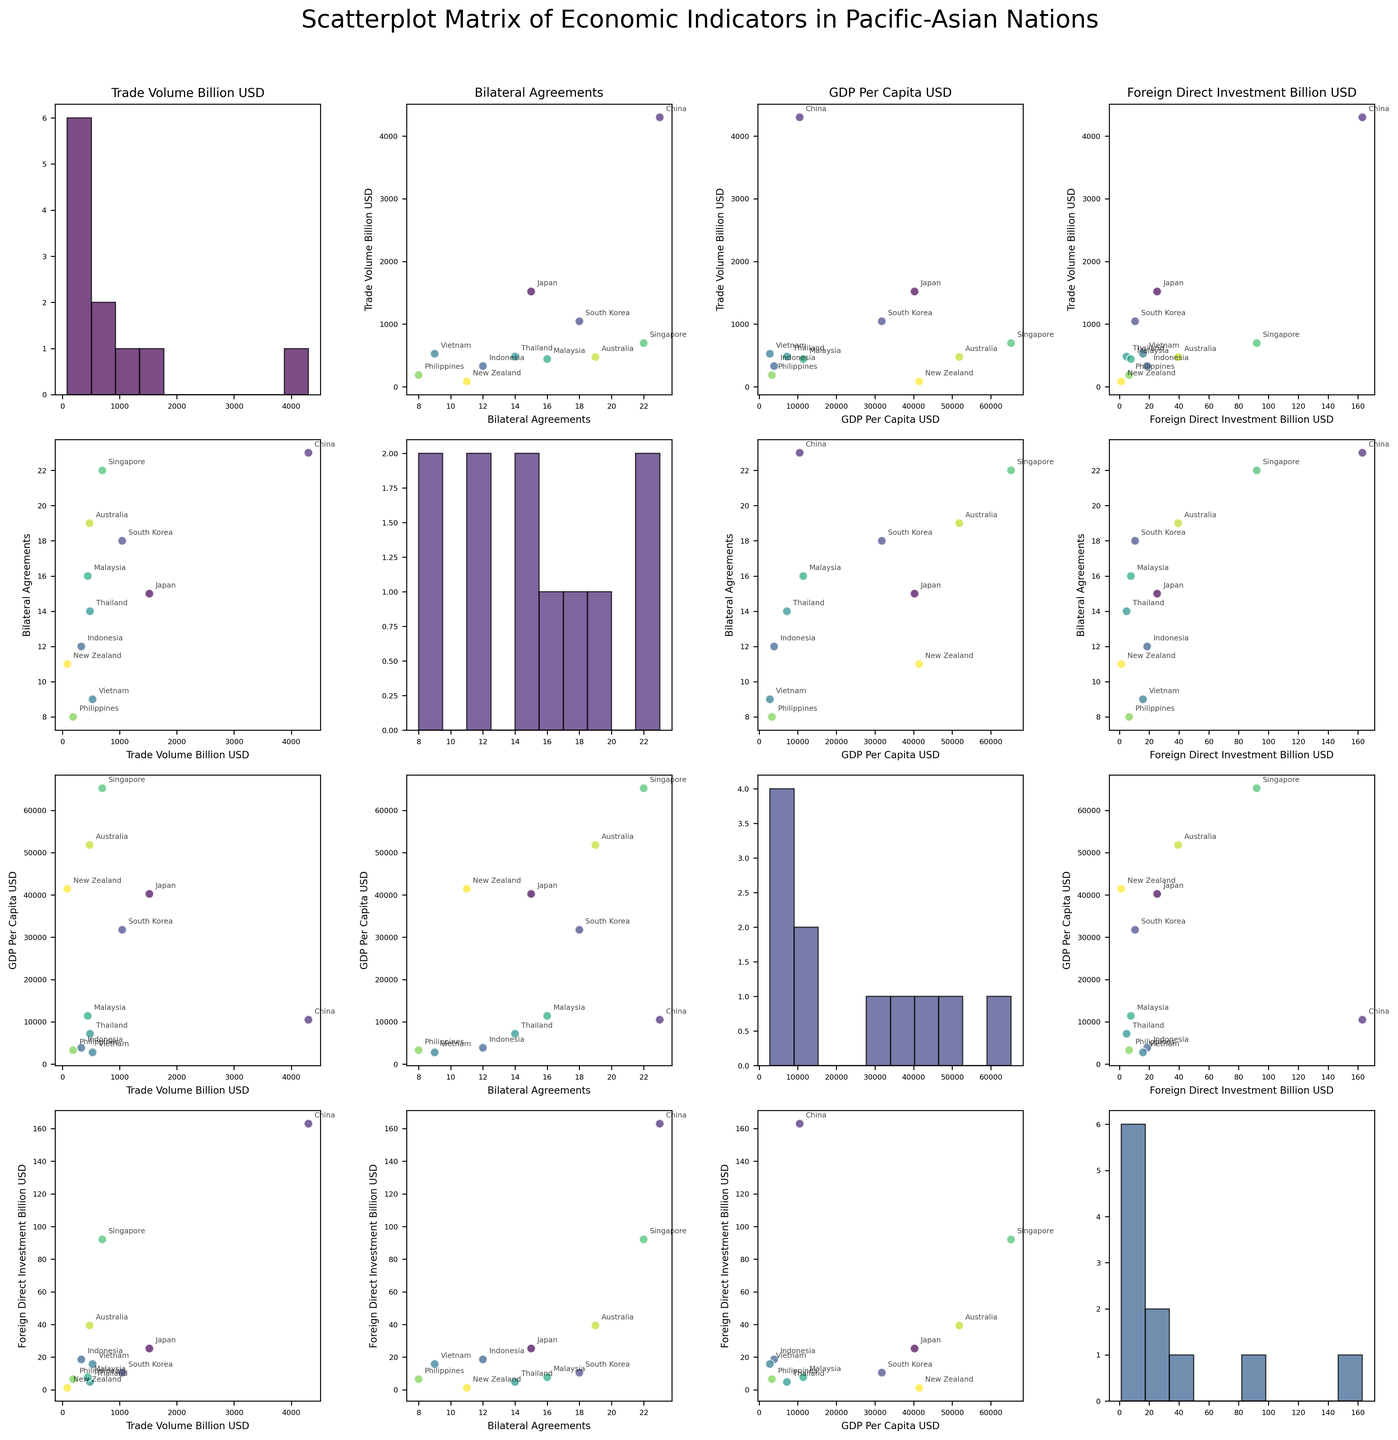Which country has the highest trade volume? By examining the scatterplot where the x-axis represents countries, you can identify that China has the highest value on the trade volume axis, indicating the highest trade volume in billion USD.
Answer: China How many bilateral agreements does South Korea have? By locating South Korea in the scatterplot matrix, you can observe that it has a value of 18 on the bilateral agreements axis.
Answer: 18 Which two countries are closest in terms of GDP per capita? By comparing the scatter plots of GDP per capita, you can observe that Japan and New Zealand have GDP per capita values that are very close to each other.
Answer: Japan and New Zealand Is there a positive correlation between Foreign Direct Investment (FDI) and Trade Volume? By observing the scatter plot between FDI and Trade Volume, you can see that countries with higher trade volumes tend to have higher FDI, indicating a positive correlation.
Answer: Yes Which country has the lowest number of bilateral agreements? By checking the axis for bilateral agreements, you can see that the Philippines has the smallest value, indicating the lowest number of bilateral agreements.
Answer: Philippines What is the relationship between Trade Volume and GDP per Capita? By inspecting the scatter plot between Trade Volume and GDP per Capita, it is noticeable that there is no clear linear relationship, as the data points are scattered without a definitive trend.
Answer: No clear relationship Which country has the highest GDP per capita? By examining the scatter plots that include GDP per capita, you can determine that Singapore has the highest value on the GDP per capita axis.
Answer: Singapore Is there a country with high GDP per capita but relatively low FDI? By looking at the scatter plot matrix, you can find that New Zealand has a high GDP per capita but relatively low FDI compared to other countries.
Answer: New Zealand Between Australia and New Zealand, which has a higher trade volume? By comparing the trade volume values for both countries on the relevant scatter plot axes, it is evident that Australia has a higher trade volume than New Zealand.
Answer: Australia What is the range of bilateral agreements among these countries? By observing the scatter plot that includes bilateral agreements, you can see that the range spans from 8 (Philippines) to 23 (China).
Answer: 8 to 23 